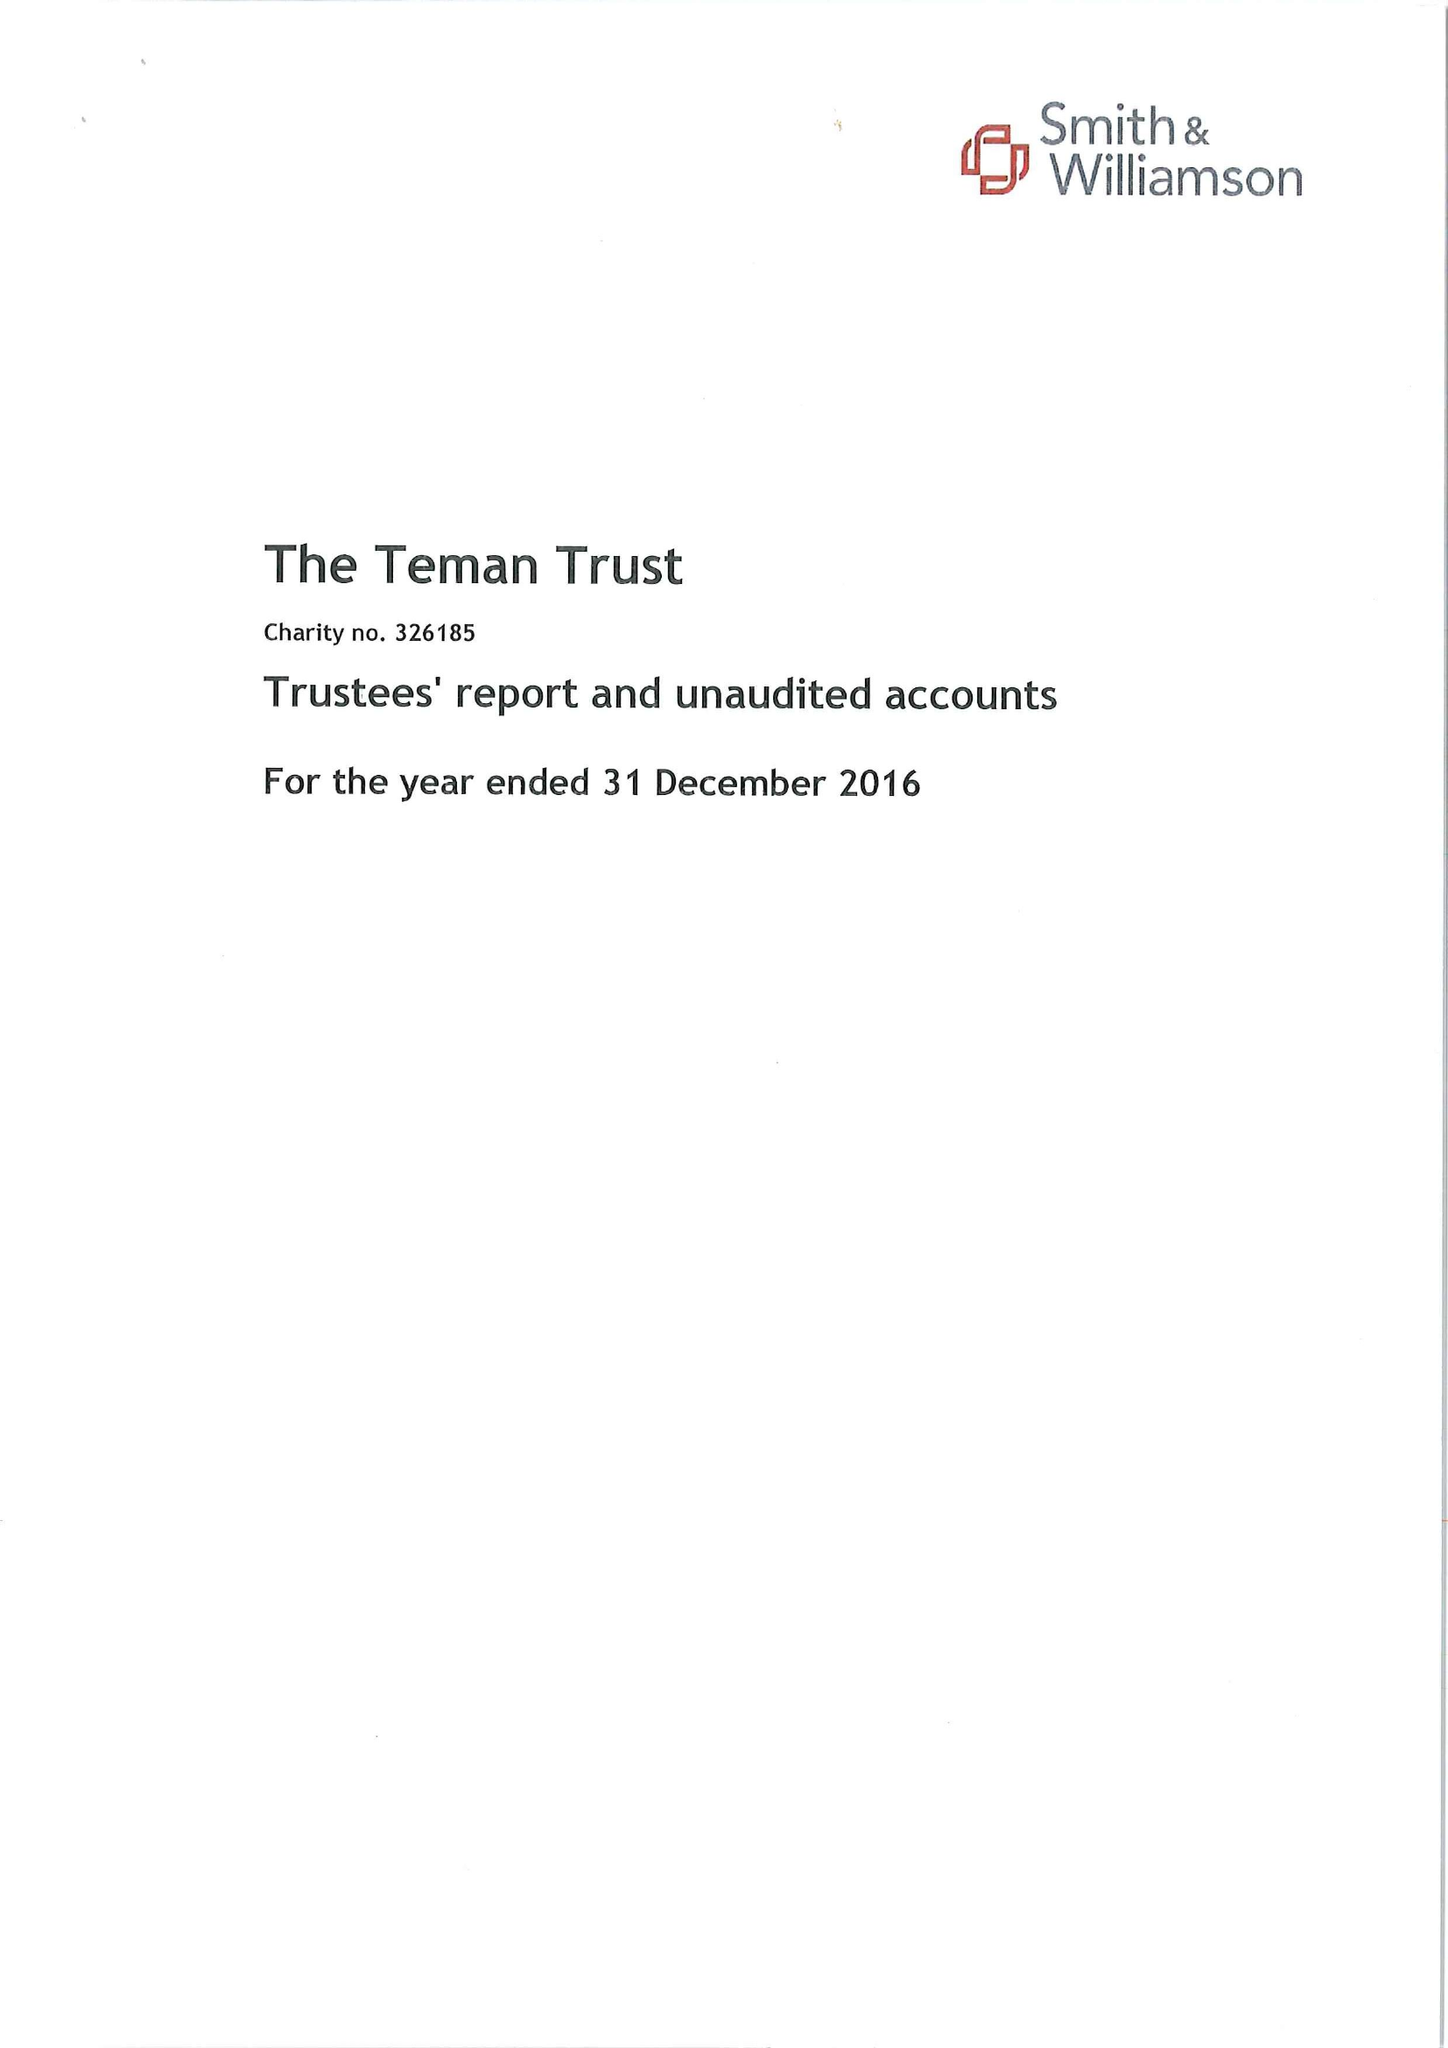What is the value for the address__post_town?
Answer the question using a single word or phrase. SOUTHAMPTON 